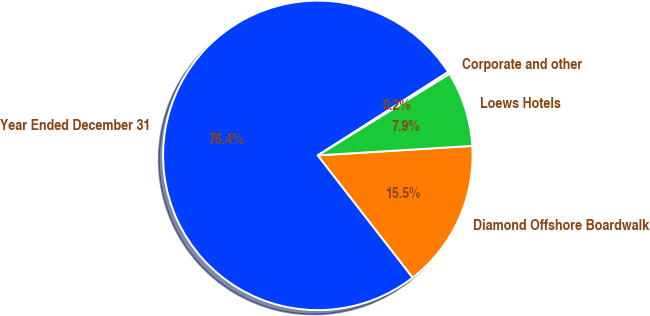Convert chart to OTSL. <chart><loc_0><loc_0><loc_500><loc_500><pie_chart><fcel>Year Ended December 31<fcel>Diamond Offshore Boardwalk<fcel>Loews Hotels<fcel>Corporate and other<nl><fcel>76.45%<fcel>15.47%<fcel>7.85%<fcel>0.23%<nl></chart> 